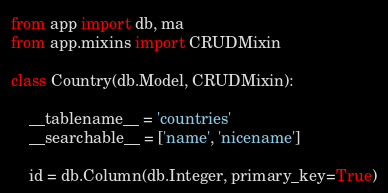<code> <loc_0><loc_0><loc_500><loc_500><_Python_>from app import db, ma
from app.mixins import CRUDMixin

class Country(db.Model, CRUDMixin):

    __tablename__ = 'countries'
    __searchable__ = ['name', 'nicename']

    id = db.Column(db.Integer, primary_key=True)</code> 